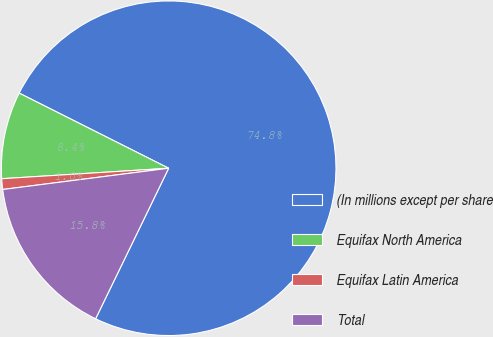Convert chart to OTSL. <chart><loc_0><loc_0><loc_500><loc_500><pie_chart><fcel>(In millions except per share<fcel>Equifax North America<fcel>Equifax Latin America<fcel>Total<nl><fcel>74.78%<fcel>8.41%<fcel>1.03%<fcel>15.78%<nl></chart> 